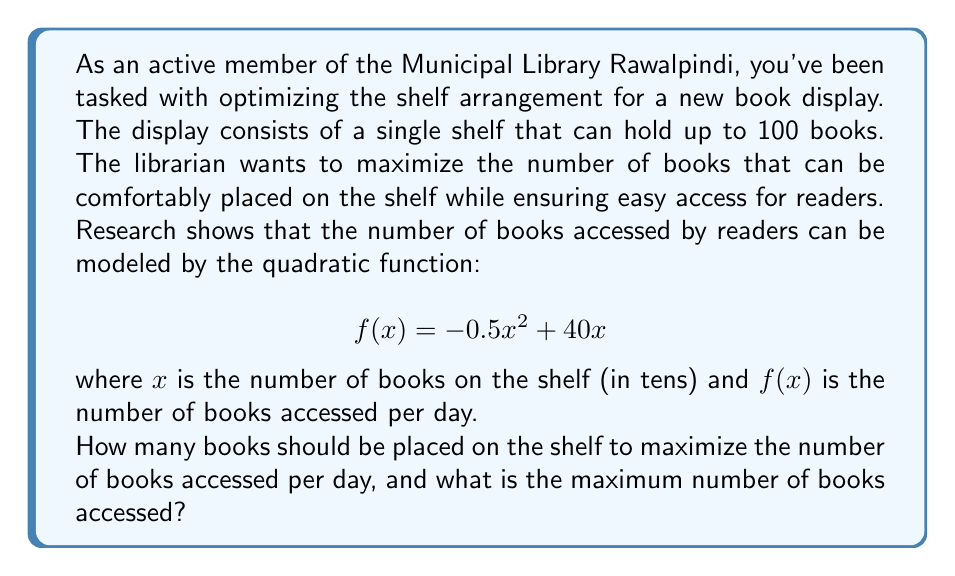Help me with this question. To solve this problem, we need to find the maximum value of the quadratic function $f(x) = -0.5x^2 + 40x$. 

1) First, let's recall that for a quadratic function in the form $f(x) = ax^2 + bx + c$, the x-coordinate of the vertex is given by $x = -\frac{b}{2a}$.

2) In our case, $a = -0.5$ and $b = 40$. So:

   $x = -\frac{40}{2(-0.5)} = -\frac{40}{-1} = 40$

3) This means that the function reaches its maximum when $x = 40$. However, remember that $x$ represents tens of books. So, the optimal number of books is $40 \times 10 = 400$ books.

4) To find the maximum number of books accessed, we need to calculate $f(40)$:

   $f(40) = -0.5(40)^2 + 40(40)$
   $= -0.5(1600) + 1600$
   $= -800 + 1600$
   $= 800$

5) However, we need to check if this solution is within the given constraints. The shelf can only hold up to 100 books, so our calculated optimal of 400 books exceeds this limit.

6) Given this constraint, the maximum number of books we can place is 100, which corresponds to $x = 10$ in our function.

7) Let's calculate $f(10)$:

   $f(10) = -0.5(10)^2 + 40(10)$
   $= -50 + 400$
   $= 350$

Therefore, within the given constraints, we should place 100 books on the shelf, which will result in 350 books being accessed per day.
Answer: The optimal number of books to place on the shelf is 100, and the maximum number of books accessed per day will be 350. 